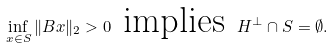<formula> <loc_0><loc_0><loc_500><loc_500>\inf _ { x \in S } \| B x \| _ { 2 } > 0 \text { implies } H ^ { \perp } \cap S = \emptyset .</formula> 